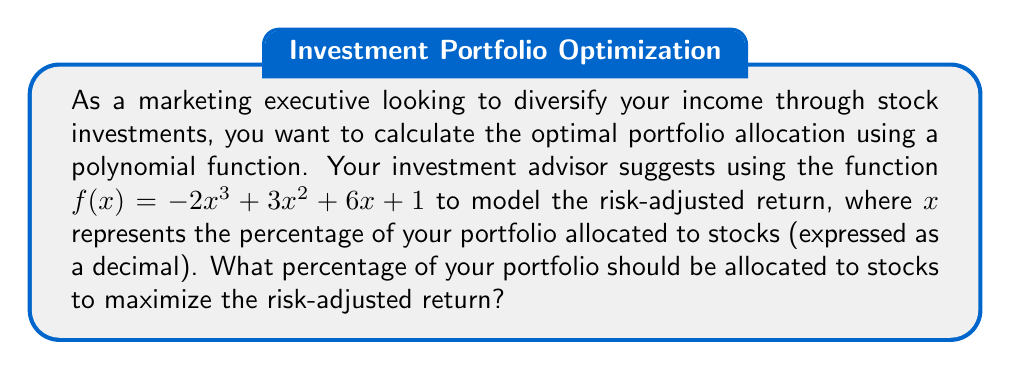Could you help me with this problem? To find the optimal allocation, we need to find the maximum value of the function $f(x) = -2x^3 + 3x^2 + 6x + 1$.

1. Calculate the first derivative:
   $f'(x) = -6x^2 + 6x + 6$

2. Set the first derivative to zero and solve for x:
   $-6x^2 + 6x + 6 = 0$
   $-6(x^2 - x - 1) = 0$
   $x^2 - x - 1 = 0$

3. Use the quadratic formula to solve:
   $x = \frac{-b \pm \sqrt{b^2 - 4ac}}{2a}$
   $x = \frac{1 \pm \sqrt{1^2 - 4(1)(-1)}}{2(1)}$
   $x = \frac{1 \pm \sqrt{5}}{2}$

4. The two solutions are:
   $x_1 = \frac{1 + \sqrt{5}}{2} \approx 1.618$ (outside our domain)
   $x_2 = \frac{1 - \sqrt{5}}{2} \approx -0.618$ (outside our domain)

5. Since both solutions are outside the domain of [0, 1] for portfolio allocation, we need to check the endpoints:
   $f(0) = 1$
   $f(1) = -2 + 3 + 6 + 1 = 8$

6. The maximum value occurs at x = 1, which corresponds to 100% allocation to stocks.
Answer: 100% 